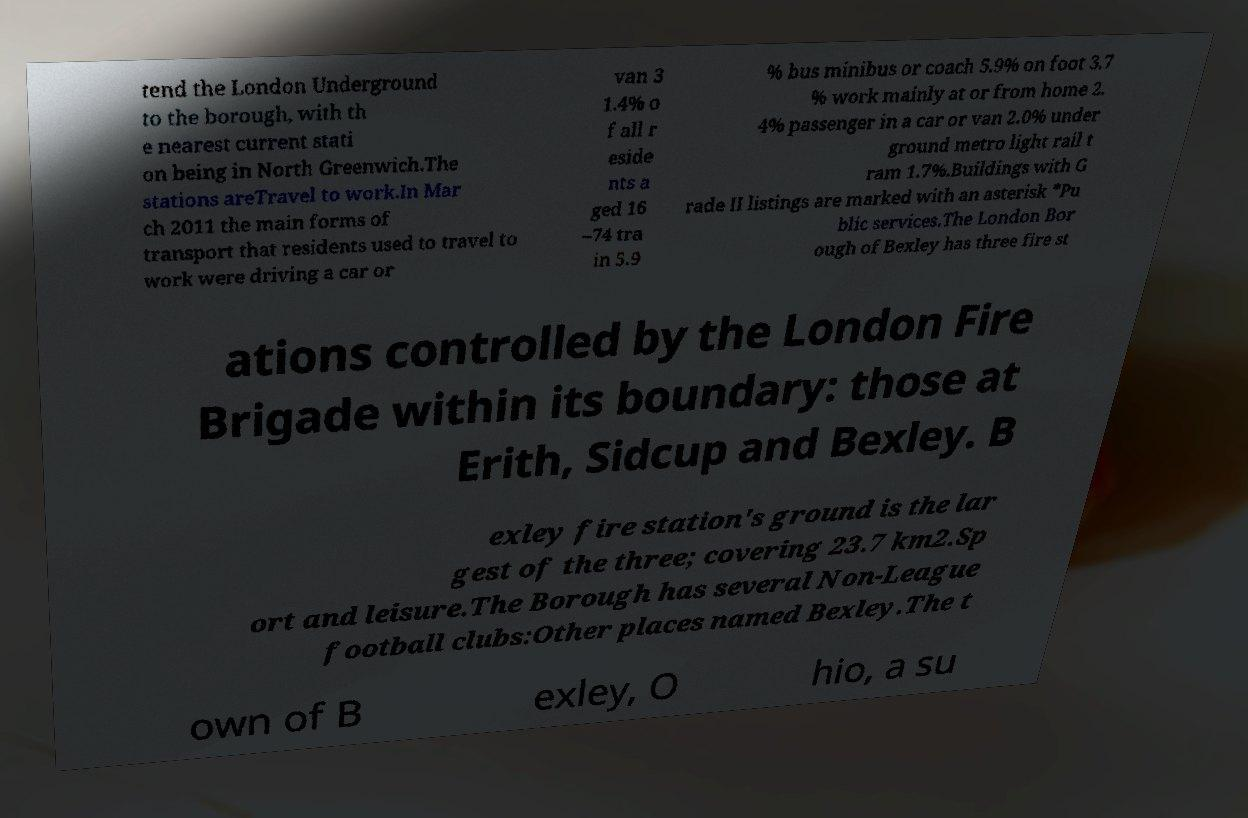There's text embedded in this image that I need extracted. Can you transcribe it verbatim? tend the London Underground to the borough, with th e nearest current stati on being in North Greenwich.The stations areTravel to work.In Mar ch 2011 the main forms of transport that residents used to travel to work were driving a car or van 3 1.4% o f all r eside nts a ged 16 –74 tra in 5.9 % bus minibus or coach 5.9% on foot 3.7 % work mainly at or from home 2. 4% passenger in a car or van 2.0% under ground metro light rail t ram 1.7%.Buildings with G rade II listings are marked with an asterisk *Pu blic services.The London Bor ough of Bexley has three fire st ations controlled by the London Fire Brigade within its boundary: those at Erith, Sidcup and Bexley. B exley fire station's ground is the lar gest of the three; covering 23.7 km2.Sp ort and leisure.The Borough has several Non-League football clubs:Other places named Bexley.The t own of B exley, O hio, a su 